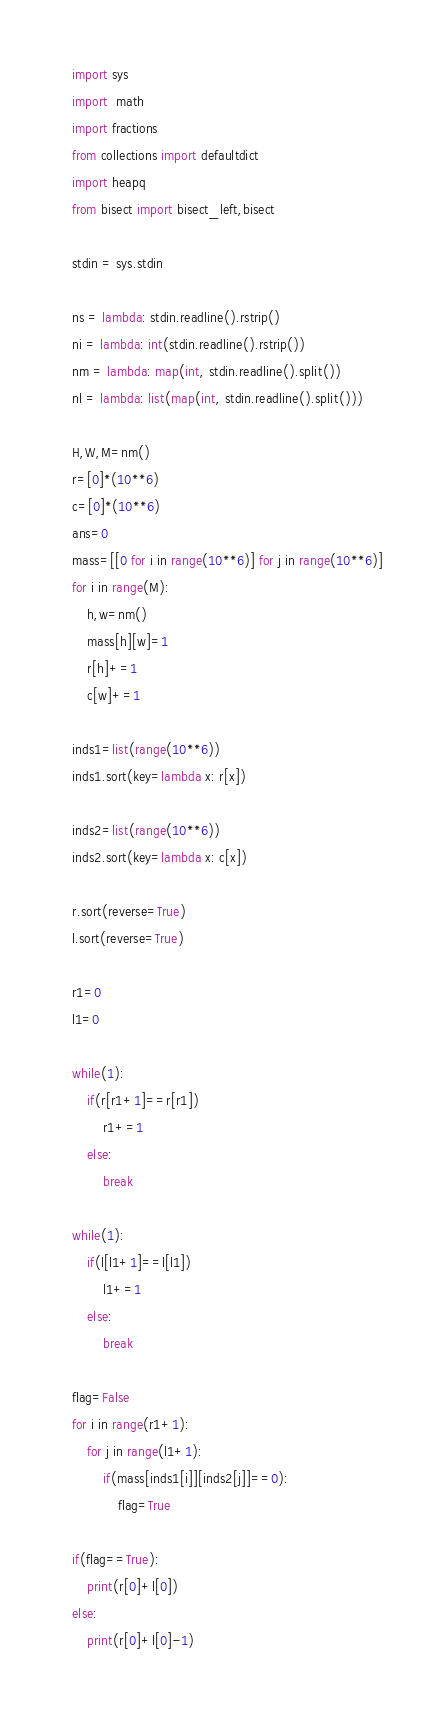Convert code to text. <code><loc_0><loc_0><loc_500><loc_500><_Python_>import sys
import  math
import fractions
from collections import defaultdict
import heapq
from bisect import bisect_left,bisect

stdin = sys.stdin
     
ns = lambda: stdin.readline().rstrip()
ni = lambda: int(stdin.readline().rstrip())
nm = lambda: map(int, stdin.readline().split())
nl = lambda: list(map(int, stdin.readline().split()))

H,W,M=nm()
r=[0]*(10**6)
c=[0]*(10**6)
ans=0
mass=[[0 for i in range(10**6)] for j in range(10**6)]
for i in range(M):
    h,w=nm()
    mass[h][w]=1
    r[h]+=1
    c[w]+=1

inds1=list(range(10**6))
inds1.sort(key=lambda x: r[x])

inds2=list(range(10**6))
inds2.sort(key=lambda x: c[x])

r.sort(reverse=True)
l.sort(reverse=True)

r1=0
l1=0

while(1):
    if(r[r1+1]==r[r1])
        r1+=1
    else:
        break

while(1):
    if(l[l1+1]==l[l1])
        l1+=1
    else:
        break

flag=False
for i in range(r1+1):
    for j in range(l1+1):
        if(mass[inds1[i]][inds2[j]]==0):
            flag=True
        
if(flag==True):
    print(r[0]+l[0])
else:
    print(r[0]+l[0]-1)




</code> 